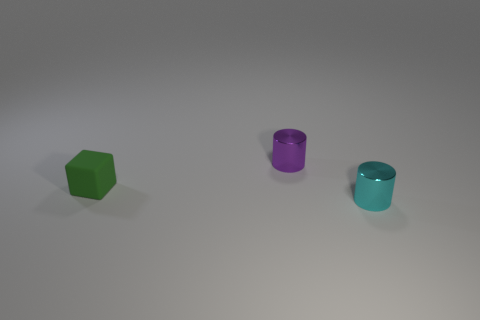Add 1 large matte cylinders. How many objects exist? 4 Subtract all purple cylinders. How many cylinders are left? 1 Subtract all cylinders. How many objects are left? 1 Subtract all matte objects. Subtract all tiny purple shiny cylinders. How many objects are left? 1 Add 1 tiny metal cylinders. How many tiny metal cylinders are left? 3 Add 3 small green matte blocks. How many small green matte blocks exist? 4 Subtract 1 purple cylinders. How many objects are left? 2 